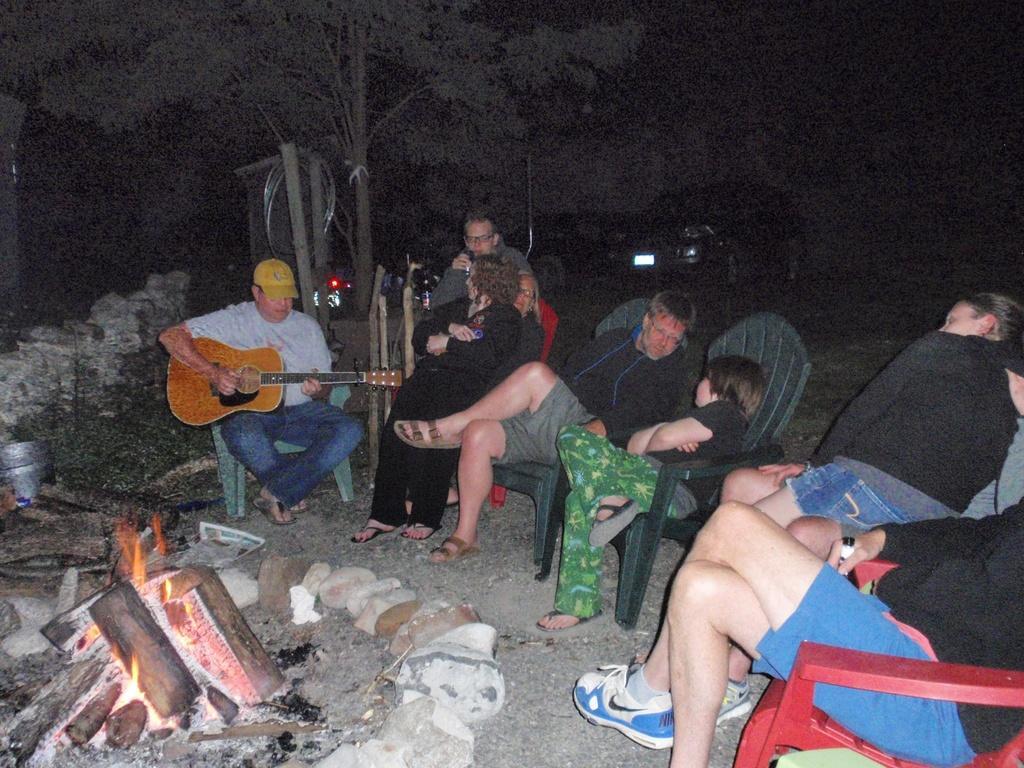How would you summarize this image in a sentence or two? In the picture are few people sitting on the chairs in an open area. The man at the left wore a cap and is playing a guitar and the man at the right is holding a bottle. There is born fire at the below left corner of the image and beside to it there are many stones. In the background there is a tree and some vehicles. 